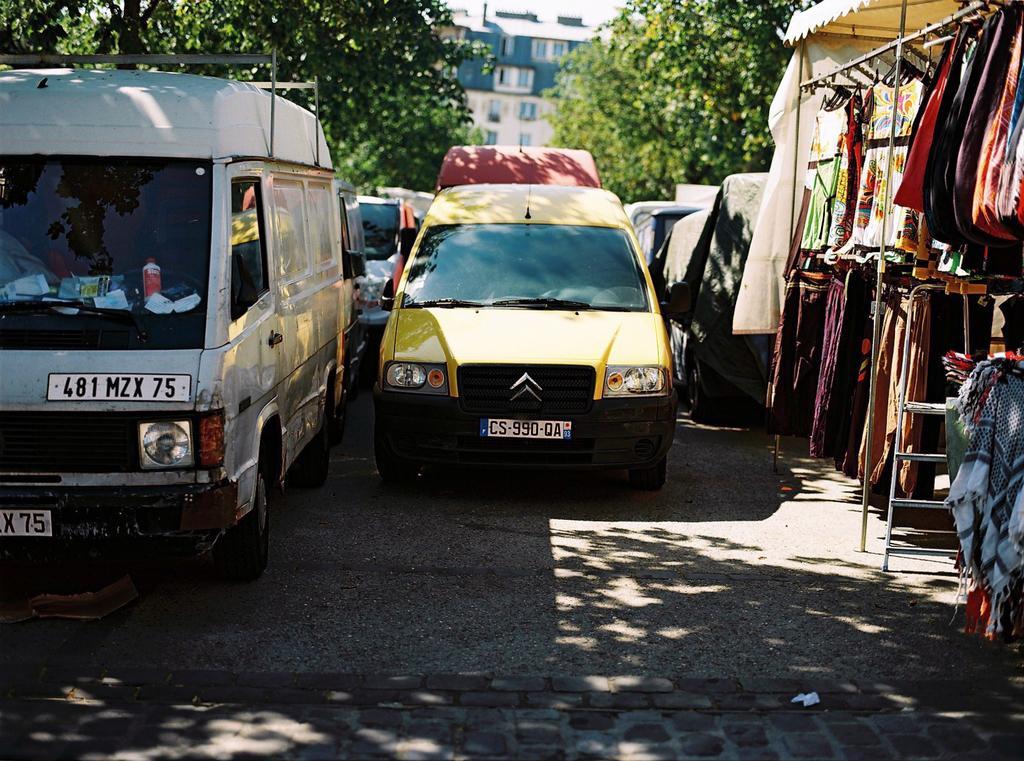Can you describe this image briefly? In the image we can see there are vehicles which are parked on the road and there are clothes kept on the hanger. Behind there are trees and there is a building. 